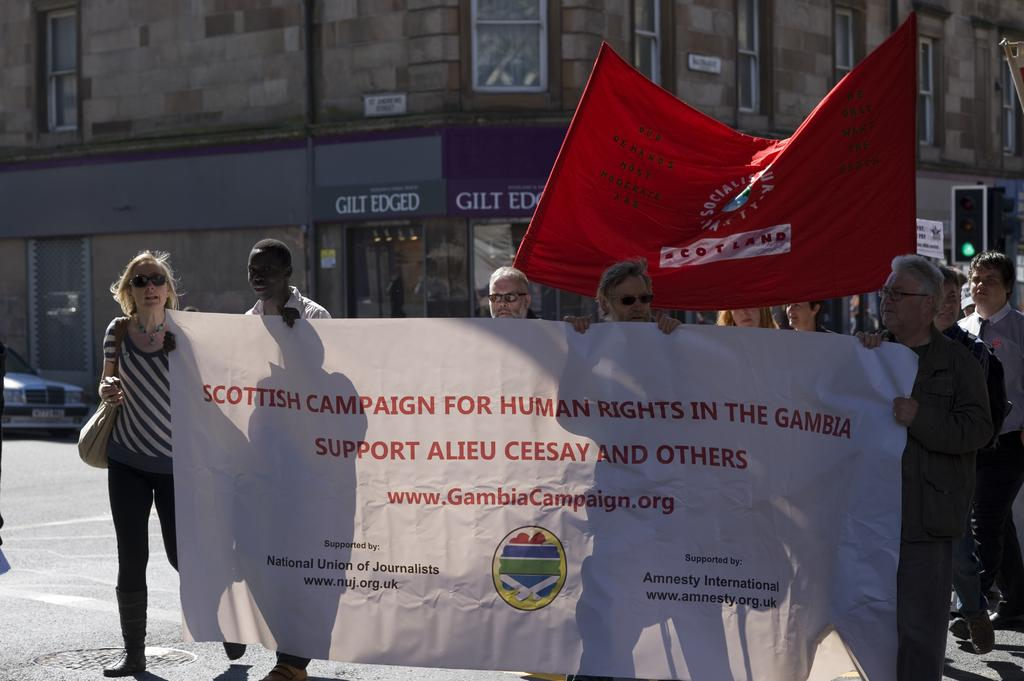What type of structure is present in the image? There is a building in the image. What additional elements can be seen in the image? There are banners and a traffic signal in the image. Are there any living beings visible in the image? Yes, there are people visible in the image. Where is the mint jar located in the image? There is no mint jar present in the image. What type of playground equipment can be seen in the image? There is no playground equipment visible in the image. 